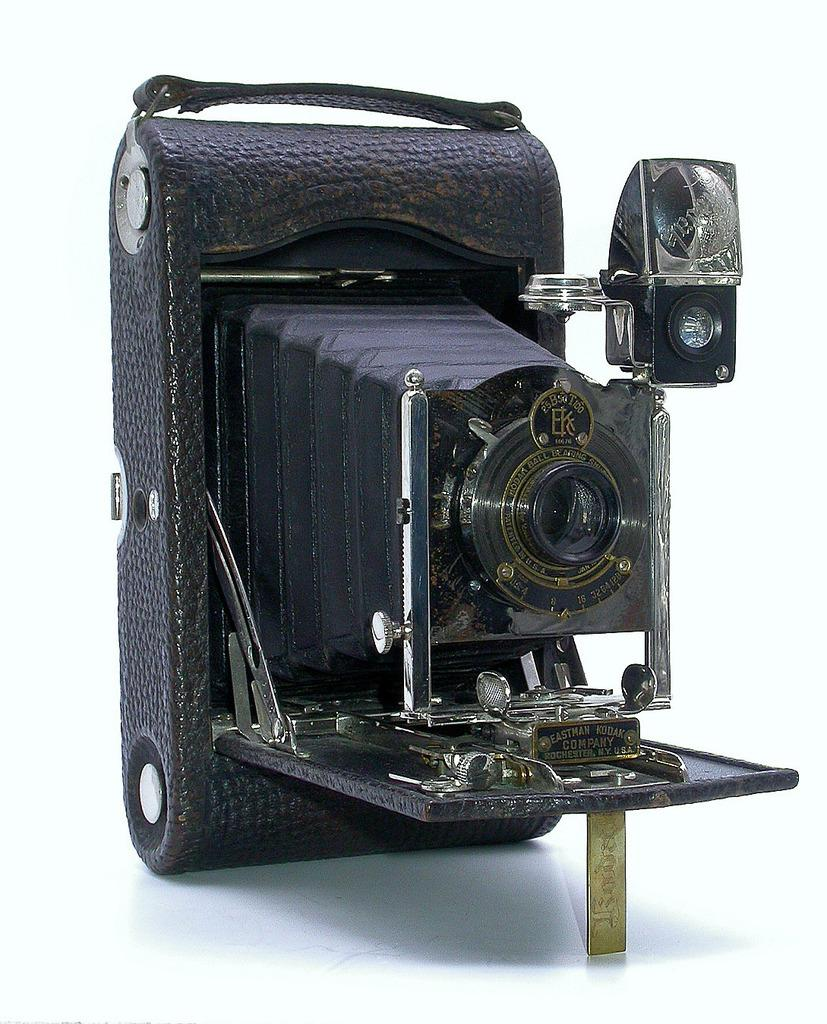What is the main object in the image? There is a camera on a white surface in the image. What color is the surface the camera is placed on? The surface is white. What can be seen in the background of the image? The background of the image is white. What type of plant is growing in the camera in the image? There is no plant growing in the camera in the image. How does the frog contribute to the digestion process in the image? There is no frog or digestion process present in the image. 